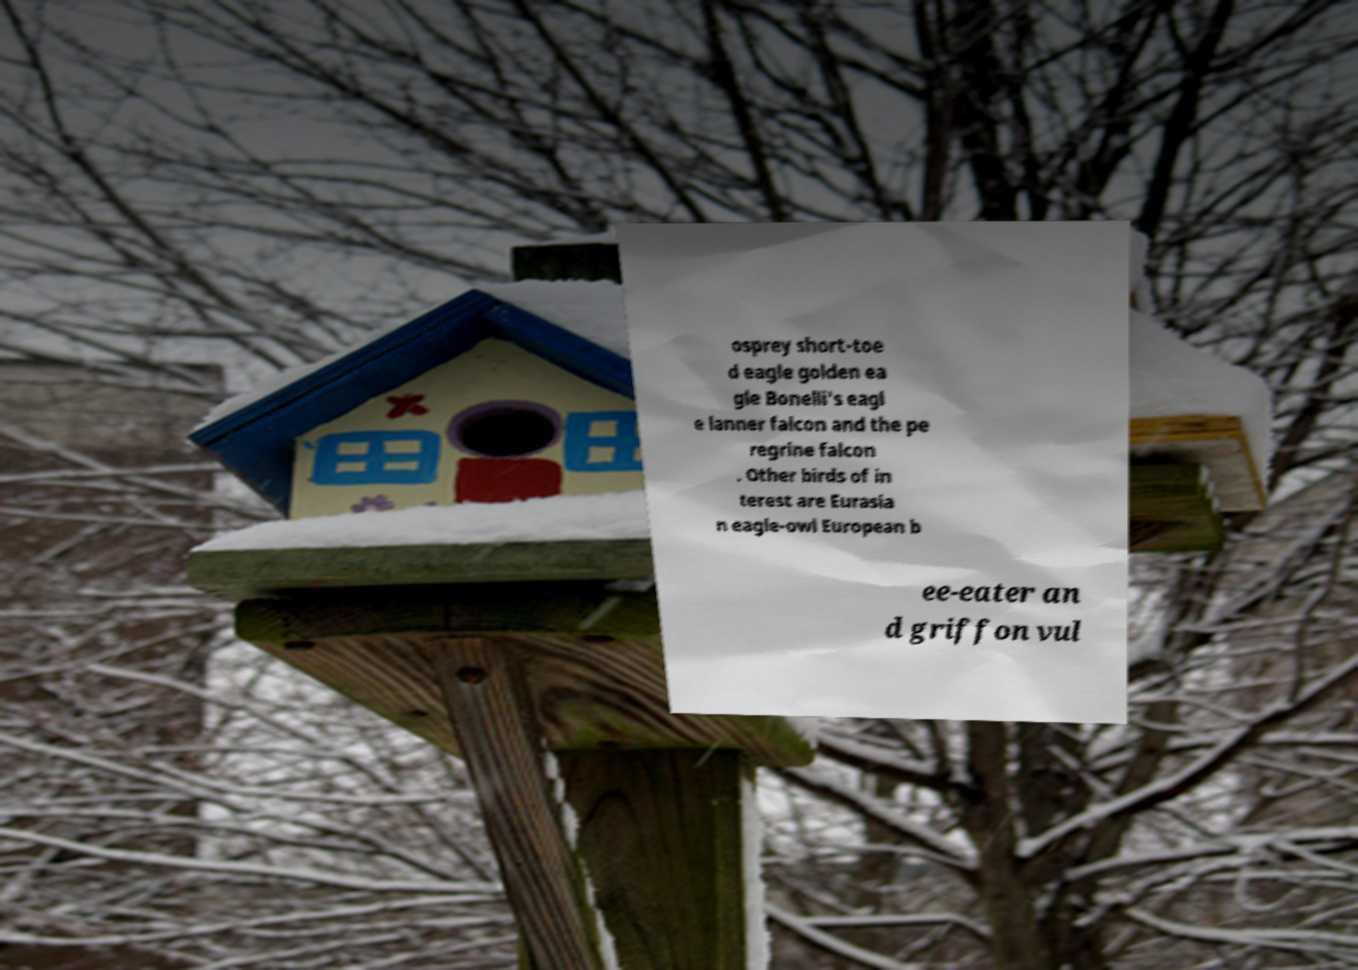Could you extract and type out the text from this image? osprey short-toe d eagle golden ea gle Bonelli's eagl e lanner falcon and the pe regrine falcon . Other birds of in terest are Eurasia n eagle-owl European b ee-eater an d griffon vul 